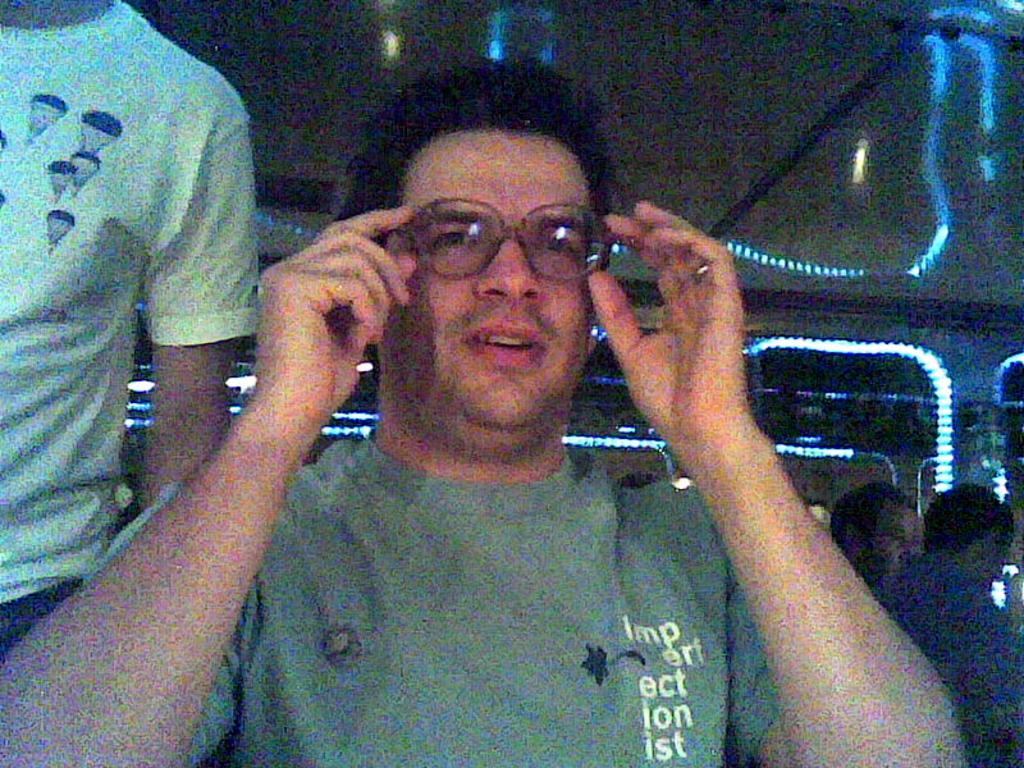What is the expression of the person in the front of the image? The person in the front of the image is smiling. Who is standing on the left side of the image? There is a man standing on the left side of the image. How many persons are on the right side of the image? There are persons on the right side of the image. What can be seen in the background of the image? There are lights visible in the background of the image. What grade does the fact receive in the image? There is no grade present in the image, as it is a photograph and not a grading system. Which nerve is responsible for the person's smile in the image? The image does not provide information about the person's physiology or the specific nerve responsible for their smile. 